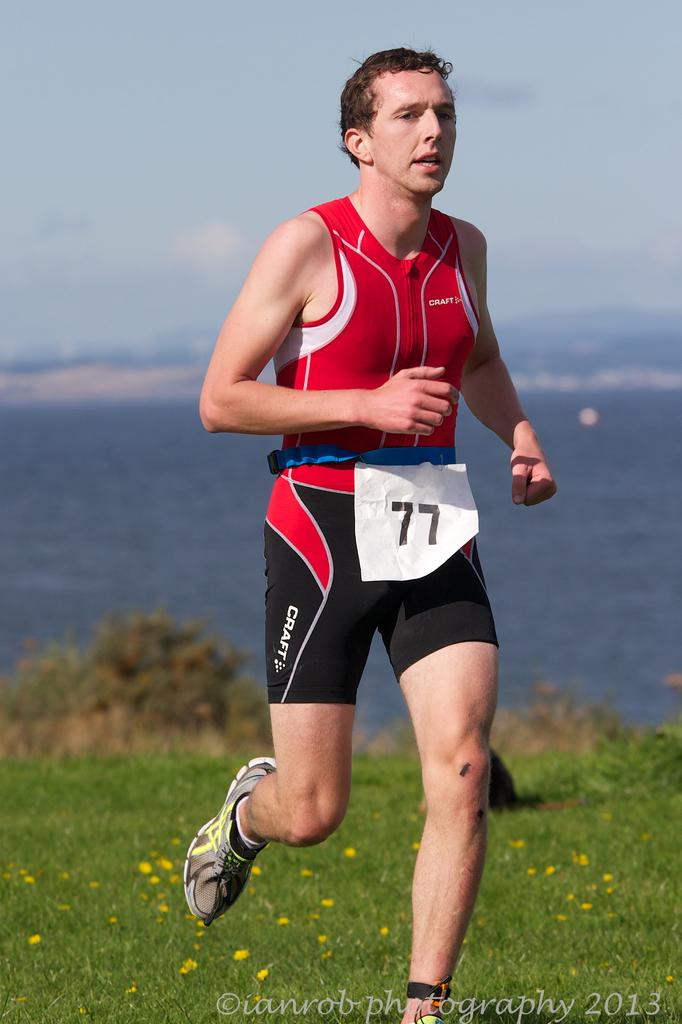<image>
Write a terse but informative summary of the picture. A person is jogging; the number 77 is on their waist. 